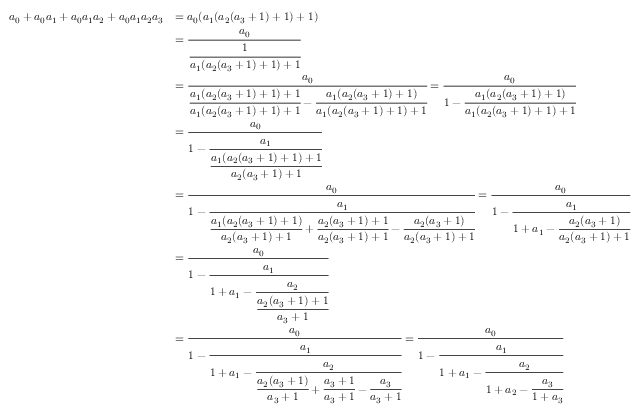Convert formula to latex. <formula><loc_0><loc_0><loc_500><loc_500>{ \begin{array} { r l } { a _ { 0 } + a _ { 0 } a _ { 1 } + a _ { 0 } a _ { 1 } a _ { 2 } + a _ { 0 } a _ { 1 } a _ { 2 } a _ { 3 } } & { = a _ { 0 } ( a _ { 1 } ( a _ { 2 } ( a _ { 3 } + 1 ) + 1 ) + 1 ) } \\ & { = { \cfrac { a _ { 0 } } { \cfrac { 1 } { a _ { 1 } ( a _ { 2 } ( a _ { 3 } + 1 ) + 1 ) + 1 } } } } \\ & { = { \cfrac { a _ { 0 } } { { \cfrac { a _ { 1 } ( a _ { 2 } ( a _ { 3 } + 1 ) + 1 ) + 1 } { a _ { 1 } ( a _ { 2 } ( a _ { 3 } + 1 ) + 1 ) + 1 } } - { \cfrac { a _ { 1 } ( a _ { 2 } ( a _ { 3 } + 1 ) + 1 ) } { a _ { 1 } ( a _ { 2 } ( a _ { 3 } + 1 ) + 1 ) + 1 } } } } = { \cfrac { a _ { 0 } } { 1 - { \cfrac { a _ { 1 } ( a _ { 2 } ( a _ { 3 } + 1 ) + 1 ) } { a _ { 1 } ( a _ { 2 } ( a _ { 3 } + 1 ) + 1 ) + 1 } } } } } \\ & { = { \cfrac { a _ { 0 } } { 1 - { \cfrac { a _ { 1 } } { \cfrac { a _ { 1 } ( a _ { 2 } ( a _ { 3 } + 1 ) + 1 ) + 1 } { a _ { 2 } ( a _ { 3 } + 1 ) + 1 } } } } } } \\ & { = { \cfrac { a _ { 0 } } { 1 - { \cfrac { a _ { 1 } } { { \cfrac { a _ { 1 } ( a _ { 2 } ( a _ { 3 } + 1 ) + 1 ) } { a _ { 2 } ( a _ { 3 } + 1 ) + 1 } } + { \cfrac { a _ { 2 } ( a _ { 3 } + 1 ) + 1 } { a _ { 2 } ( a _ { 3 } + 1 ) + 1 } } - { \cfrac { a _ { 2 } ( a _ { 3 } + 1 ) } { a _ { 2 } ( a _ { 3 } + 1 ) + 1 } } } } } } = { \cfrac { a _ { 0 } } { 1 - { \cfrac { a _ { 1 } } { 1 + a _ { 1 } - { \cfrac { a _ { 2 } ( a _ { 3 } + 1 ) } { a _ { 2 } ( a _ { 3 } + 1 ) + 1 } } } } } } } \\ & { = { \cfrac { a _ { 0 } } { 1 - { \cfrac { a _ { 1 } } { 1 + a _ { 1 } - { \cfrac { a _ { 2 } } { \cfrac { a _ { 2 } ( a _ { 3 } + 1 ) + 1 } { a _ { 3 } + 1 } } } } } } } } \\ & { = { \cfrac { a _ { 0 } } { 1 - { \cfrac { a _ { 1 } } { 1 + a _ { 1 } - { \cfrac { a _ { 2 } } { { \cfrac { a _ { 2 } ( a _ { 3 } + 1 ) } { a _ { 3 } + 1 } } + { \cfrac { a _ { 3 } + 1 } { a _ { 3 } + 1 } } - { \cfrac { a _ { 3 } } { a _ { 3 } + 1 } } } } } } } } = { \cfrac { a _ { 0 } } { 1 - { \cfrac { a _ { 1 } } { 1 + a _ { 1 } - { \cfrac { a _ { 2 } } { 1 + a _ { 2 } - { \cfrac { a _ { 3 } } { 1 + a _ { 3 } } } } } } } } } } \end{array} }</formula> 